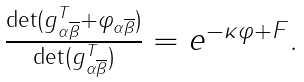<formula> <loc_0><loc_0><loc_500><loc_500>\begin{array} [ c ] { c } \frac { \det ( g _ { \alpha \overline { \beta } } ^ { T } + \varphi _ { \alpha \overline { \beta } } ) } { \det ( g _ { \alpha \overline { \beta } } ^ { T } ) } = e ^ { - \kappa \varphi + F } . \end{array}</formula> 